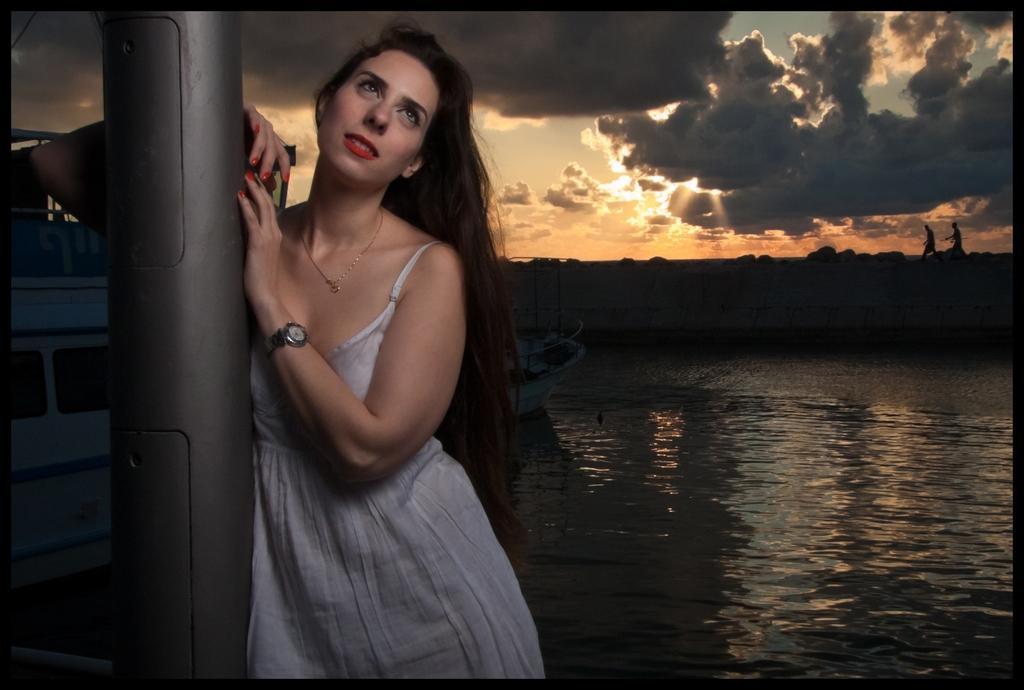How would you summarize this image in a sentence or two? In this image there is a girl standing near a pole, in the background there is a ship on the river and there are two people walking and there is the sky. 